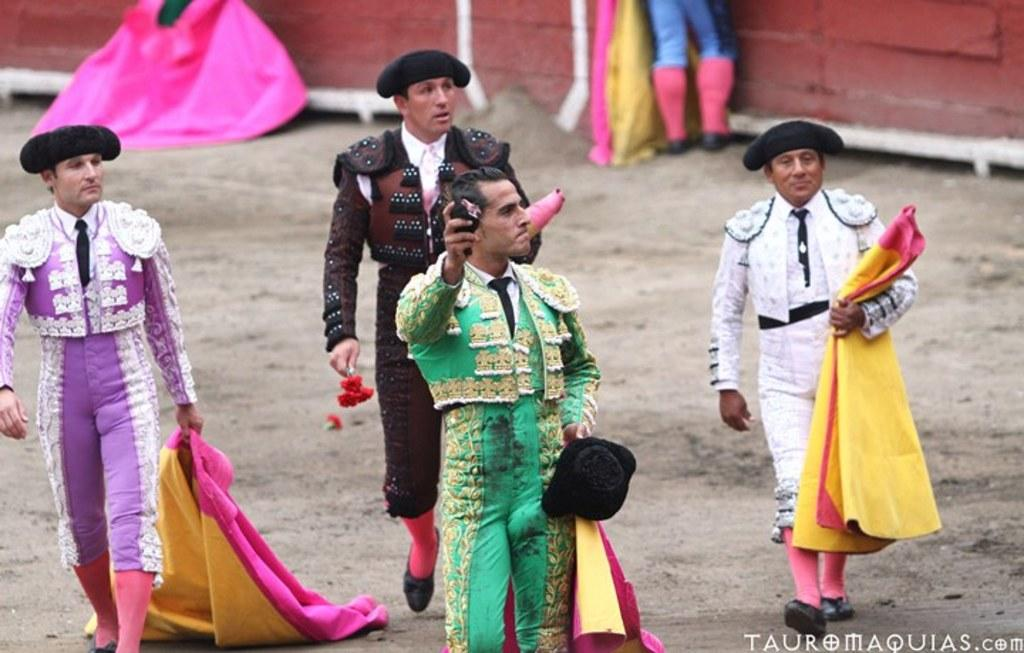How many people are present in the image? There are four people in the image. What is the man holding in the image? One man is holding a hat and an object. What are the other two people holding in the image? Two people are holding clothes. What color is the wall in the image? There is a red wall in the image. What part of a person's body is visible in front of the red wall? A person's legs are visible in front of the red wall. What type of mitten is being used to break the cracker in the image? There is no mitten or cracker present in the image. 